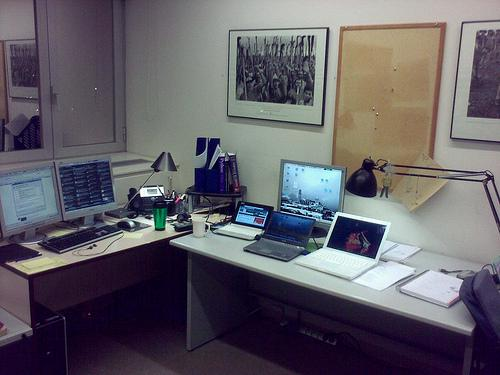Question: where was this taken?
Choices:
A. At the doctor's office.
B. At the bank.
C. At a workplace office.
D. At the hotel.
Answer with the letter. Answer: C Question: what side is the phone on?
Choices:
A. Right.
B. No phone.
C. Bottom of picture.
D. The left side.
Answer with the letter. Answer: D 